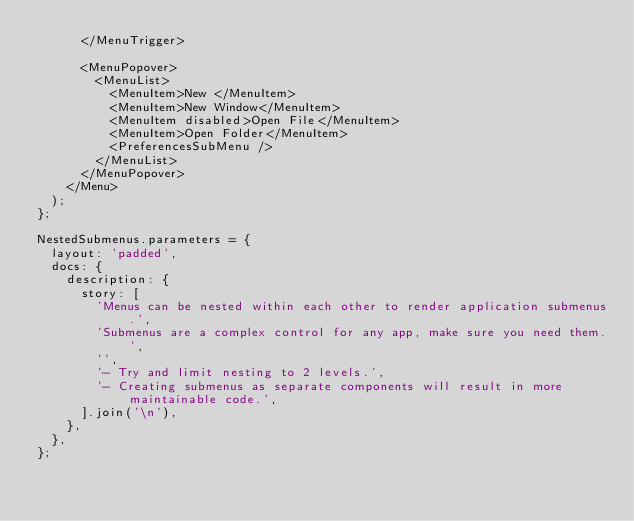<code> <loc_0><loc_0><loc_500><loc_500><_TypeScript_>      </MenuTrigger>

      <MenuPopover>
        <MenuList>
          <MenuItem>New </MenuItem>
          <MenuItem>New Window</MenuItem>
          <MenuItem disabled>Open File</MenuItem>
          <MenuItem>Open Folder</MenuItem>
          <PreferencesSubMenu />
        </MenuList>
      </MenuPopover>
    </Menu>
  );
};

NestedSubmenus.parameters = {
  layout: 'padded',
  docs: {
    description: {
      story: [
        'Menus can be nested within each other to render application submenus.',
        'Submenus are a complex control for any app, make sure you need them.',
        '',
        '- Try and limit nesting to 2 levels.',
        '- Creating submenus as separate components will result in more maintainable code.',
      ].join('\n'),
    },
  },
};
</code> 